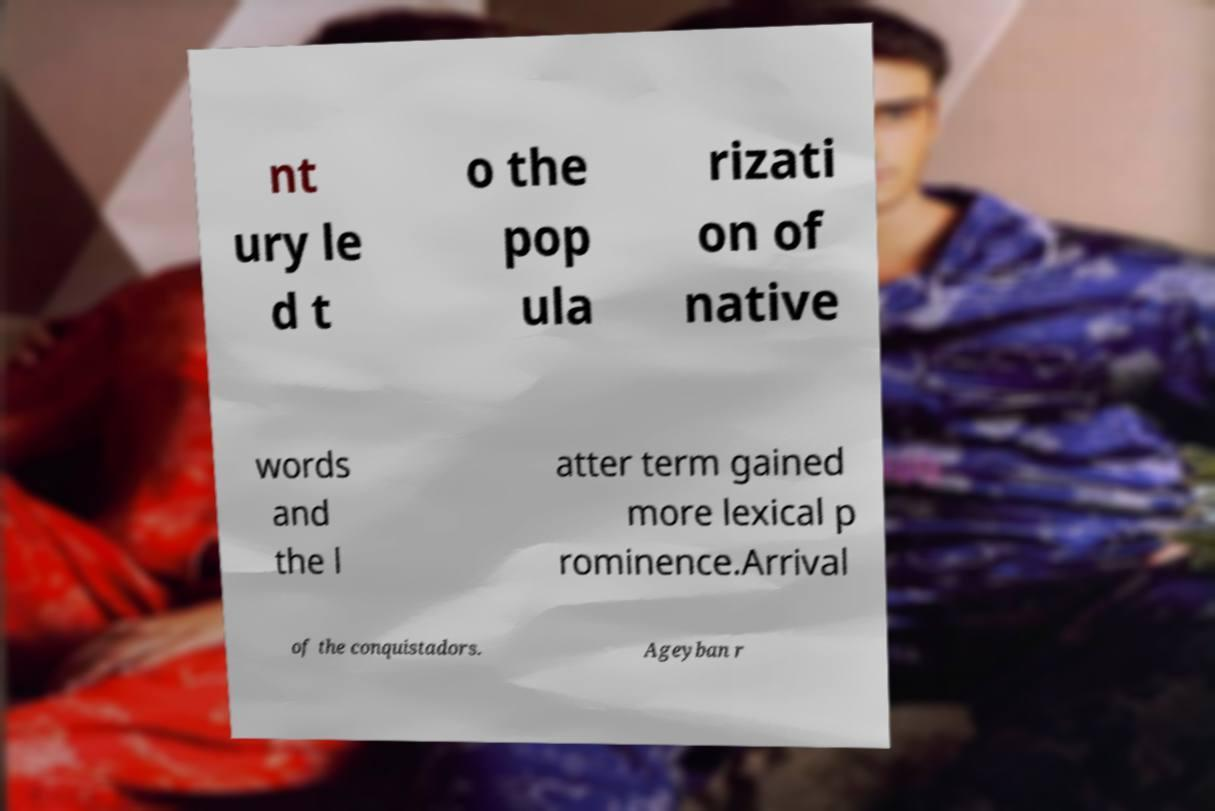There's text embedded in this image that I need extracted. Can you transcribe it verbatim? nt ury le d t o the pop ula rizati on of native words and the l atter term gained more lexical p rominence.Arrival of the conquistadors. Ageyban r 